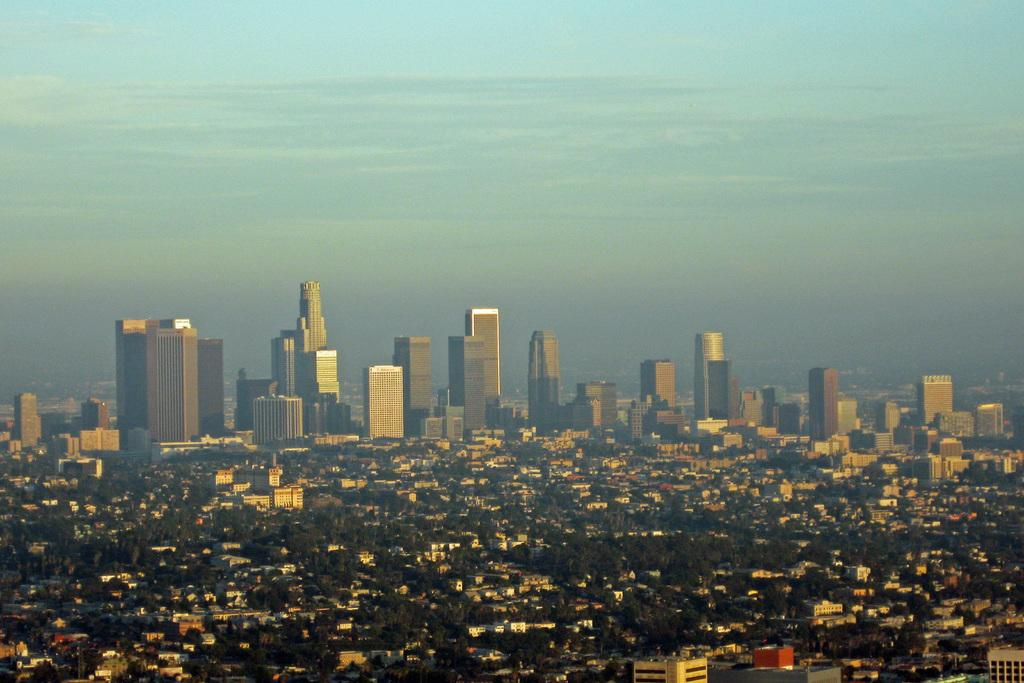What type of view is provided in the image? The image provides an aerial view. What structures can be seen from this perspective? There are buildings visible in the image. What type of natural elements can be seen in the image? There are trees visible in the image. What is visible at the top of the image? The sky is visible at the top of the image. Where are the seeds being sorted in the image? There are no seeds or sorting activity present in the image. What type of plantation can be seen in the image? There is no plantation visible in the image; it features an aerial view of buildings and trees. 